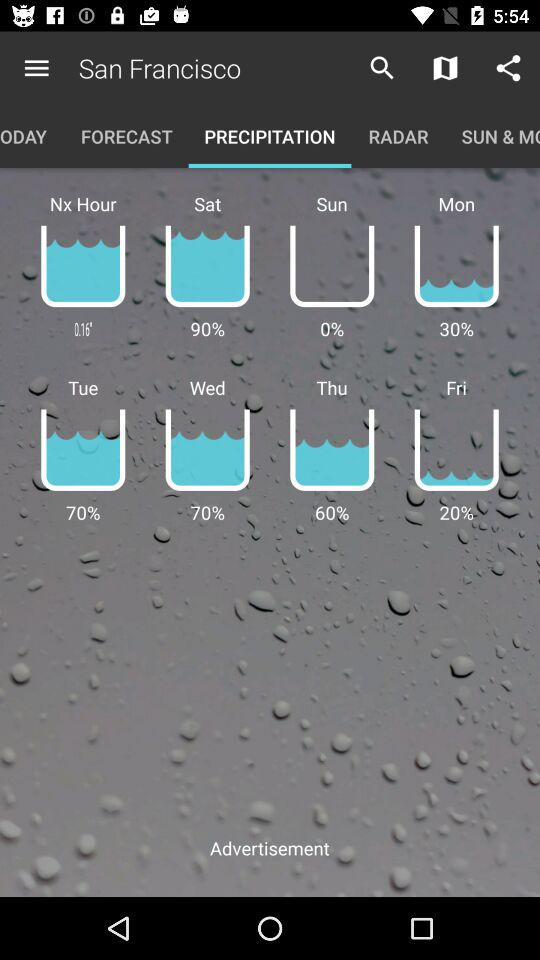On what day is there no water? There is no water on Sunday. 